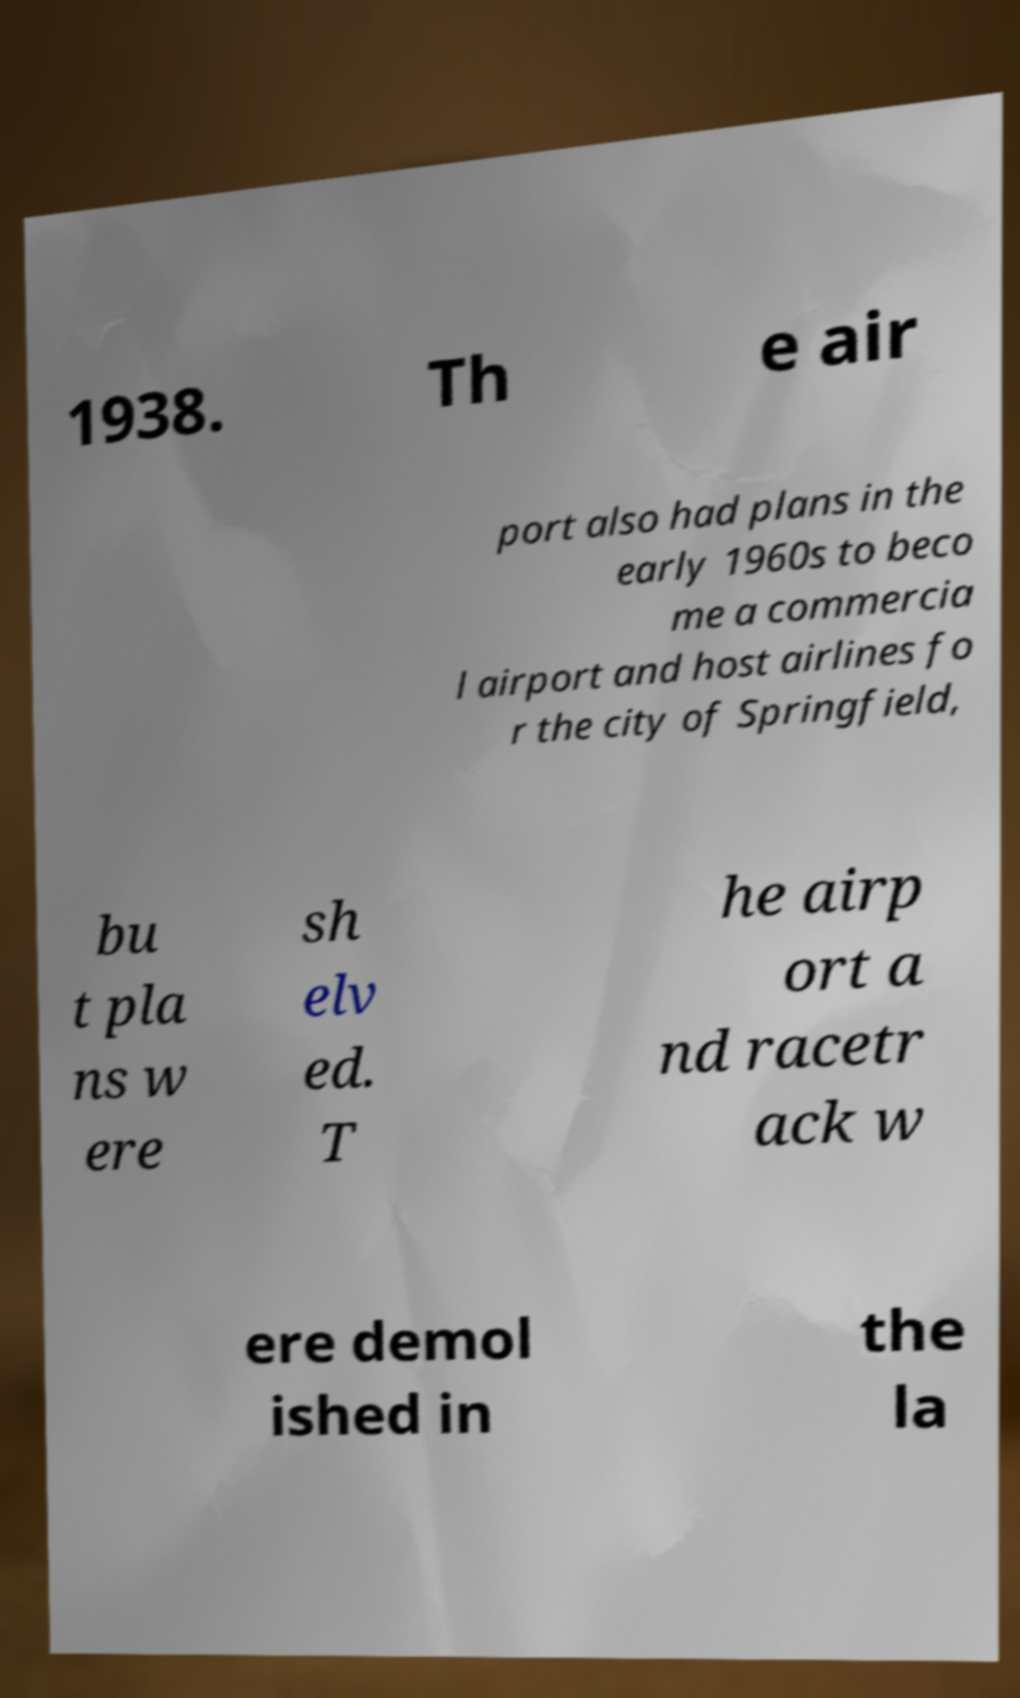Can you accurately transcribe the text from the provided image for me? 1938. Th e air port also had plans in the early 1960s to beco me a commercia l airport and host airlines fo r the city of Springfield, bu t pla ns w ere sh elv ed. T he airp ort a nd racetr ack w ere demol ished in the la 